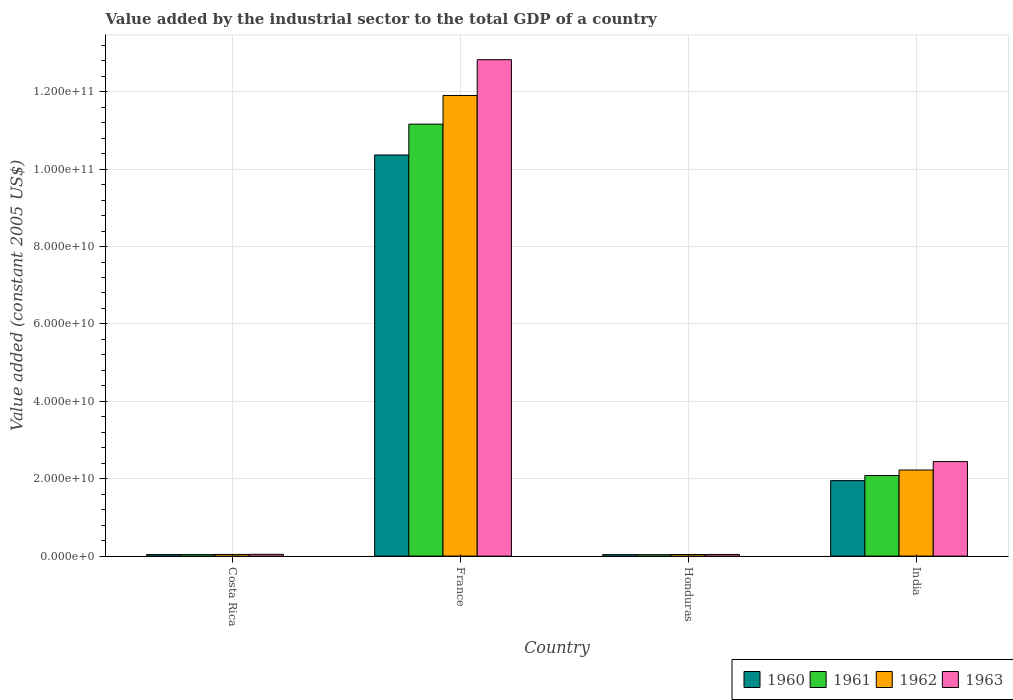How many different coloured bars are there?
Your response must be concise. 4. How many groups of bars are there?
Provide a succinct answer. 4. Are the number of bars per tick equal to the number of legend labels?
Ensure brevity in your answer.  Yes. What is the label of the 1st group of bars from the left?
Offer a very short reply. Costa Rica. In how many cases, is the number of bars for a given country not equal to the number of legend labels?
Provide a short and direct response. 0. What is the value added by the industrial sector in 1963 in Costa Rica?
Give a very brief answer. 4.68e+08. Across all countries, what is the maximum value added by the industrial sector in 1960?
Your answer should be compact. 1.04e+11. Across all countries, what is the minimum value added by the industrial sector in 1962?
Ensure brevity in your answer.  4.16e+08. In which country was the value added by the industrial sector in 1961 minimum?
Offer a very short reply. Honduras. What is the total value added by the industrial sector in 1961 in the graph?
Your answer should be very brief. 1.33e+11. What is the difference between the value added by the industrial sector in 1963 in Costa Rica and that in Honduras?
Keep it short and to the point. 4.49e+07. What is the difference between the value added by the industrial sector in 1960 in Costa Rica and the value added by the industrial sector in 1962 in France?
Ensure brevity in your answer.  -1.19e+11. What is the average value added by the industrial sector in 1963 per country?
Your answer should be compact. 3.84e+1. What is the difference between the value added by the industrial sector of/in 1961 and value added by the industrial sector of/in 1963 in Honduras?
Provide a short and direct response. -5.72e+07. What is the ratio of the value added by the industrial sector in 1960 in Costa Rica to that in France?
Provide a short and direct response. 0. Is the value added by the industrial sector in 1963 in France less than that in Honduras?
Your response must be concise. No. Is the difference between the value added by the industrial sector in 1961 in Costa Rica and India greater than the difference between the value added by the industrial sector in 1963 in Costa Rica and India?
Your answer should be very brief. Yes. What is the difference between the highest and the second highest value added by the industrial sector in 1962?
Give a very brief answer. 1.19e+11. What is the difference between the highest and the lowest value added by the industrial sector in 1961?
Keep it short and to the point. 1.11e+11. What does the 2nd bar from the left in Honduras represents?
Ensure brevity in your answer.  1961. What does the 3rd bar from the right in France represents?
Give a very brief answer. 1961. Are all the bars in the graph horizontal?
Offer a very short reply. No. Does the graph contain grids?
Ensure brevity in your answer.  Yes. Where does the legend appear in the graph?
Offer a very short reply. Bottom right. How are the legend labels stacked?
Provide a short and direct response. Horizontal. What is the title of the graph?
Offer a very short reply. Value added by the industrial sector to the total GDP of a country. Does "1986" appear as one of the legend labels in the graph?
Give a very brief answer. No. What is the label or title of the Y-axis?
Provide a succinct answer. Value added (constant 2005 US$). What is the Value added (constant 2005 US$) in 1960 in Costa Rica?
Your answer should be very brief. 3.98e+08. What is the Value added (constant 2005 US$) of 1961 in Costa Rica?
Offer a very short reply. 3.94e+08. What is the Value added (constant 2005 US$) of 1962 in Costa Rica?
Your response must be concise. 4.27e+08. What is the Value added (constant 2005 US$) of 1963 in Costa Rica?
Offer a very short reply. 4.68e+08. What is the Value added (constant 2005 US$) in 1960 in France?
Provide a short and direct response. 1.04e+11. What is the Value added (constant 2005 US$) in 1961 in France?
Keep it short and to the point. 1.12e+11. What is the Value added (constant 2005 US$) of 1962 in France?
Ensure brevity in your answer.  1.19e+11. What is the Value added (constant 2005 US$) in 1963 in France?
Your response must be concise. 1.28e+11. What is the Value added (constant 2005 US$) in 1960 in Honduras?
Provide a succinct answer. 3.75e+08. What is the Value added (constant 2005 US$) of 1961 in Honduras?
Provide a succinct answer. 3.66e+08. What is the Value added (constant 2005 US$) in 1962 in Honduras?
Your answer should be compact. 4.16e+08. What is the Value added (constant 2005 US$) of 1963 in Honduras?
Offer a terse response. 4.23e+08. What is the Value added (constant 2005 US$) in 1960 in India?
Provide a succinct answer. 1.95e+1. What is the Value added (constant 2005 US$) of 1961 in India?
Offer a terse response. 2.08e+1. What is the Value added (constant 2005 US$) of 1962 in India?
Ensure brevity in your answer.  2.22e+1. What is the Value added (constant 2005 US$) in 1963 in India?
Provide a succinct answer. 2.44e+1. Across all countries, what is the maximum Value added (constant 2005 US$) in 1960?
Ensure brevity in your answer.  1.04e+11. Across all countries, what is the maximum Value added (constant 2005 US$) of 1961?
Provide a short and direct response. 1.12e+11. Across all countries, what is the maximum Value added (constant 2005 US$) of 1962?
Your response must be concise. 1.19e+11. Across all countries, what is the maximum Value added (constant 2005 US$) of 1963?
Provide a succinct answer. 1.28e+11. Across all countries, what is the minimum Value added (constant 2005 US$) of 1960?
Offer a terse response. 3.75e+08. Across all countries, what is the minimum Value added (constant 2005 US$) in 1961?
Provide a succinct answer. 3.66e+08. Across all countries, what is the minimum Value added (constant 2005 US$) in 1962?
Provide a succinct answer. 4.16e+08. Across all countries, what is the minimum Value added (constant 2005 US$) in 1963?
Give a very brief answer. 4.23e+08. What is the total Value added (constant 2005 US$) in 1960 in the graph?
Offer a very short reply. 1.24e+11. What is the total Value added (constant 2005 US$) in 1961 in the graph?
Offer a very short reply. 1.33e+11. What is the total Value added (constant 2005 US$) in 1962 in the graph?
Your answer should be very brief. 1.42e+11. What is the total Value added (constant 2005 US$) of 1963 in the graph?
Your response must be concise. 1.54e+11. What is the difference between the Value added (constant 2005 US$) of 1960 in Costa Rica and that in France?
Ensure brevity in your answer.  -1.03e+11. What is the difference between the Value added (constant 2005 US$) of 1961 in Costa Rica and that in France?
Make the answer very short. -1.11e+11. What is the difference between the Value added (constant 2005 US$) of 1962 in Costa Rica and that in France?
Make the answer very short. -1.19e+11. What is the difference between the Value added (constant 2005 US$) in 1963 in Costa Rica and that in France?
Give a very brief answer. -1.28e+11. What is the difference between the Value added (constant 2005 US$) in 1960 in Costa Rica and that in Honduras?
Offer a very short reply. 2.26e+07. What is the difference between the Value added (constant 2005 US$) in 1961 in Costa Rica and that in Honduras?
Provide a short and direct response. 2.78e+07. What is the difference between the Value added (constant 2005 US$) in 1962 in Costa Rica and that in Honduras?
Provide a succinct answer. 1.10e+07. What is the difference between the Value added (constant 2005 US$) of 1963 in Costa Rica and that in Honduras?
Ensure brevity in your answer.  4.49e+07. What is the difference between the Value added (constant 2005 US$) in 1960 in Costa Rica and that in India?
Keep it short and to the point. -1.91e+1. What is the difference between the Value added (constant 2005 US$) of 1961 in Costa Rica and that in India?
Ensure brevity in your answer.  -2.04e+1. What is the difference between the Value added (constant 2005 US$) of 1962 in Costa Rica and that in India?
Ensure brevity in your answer.  -2.18e+1. What is the difference between the Value added (constant 2005 US$) of 1963 in Costa Rica and that in India?
Offer a very short reply. -2.40e+1. What is the difference between the Value added (constant 2005 US$) in 1960 in France and that in Honduras?
Keep it short and to the point. 1.03e+11. What is the difference between the Value added (constant 2005 US$) of 1961 in France and that in Honduras?
Provide a succinct answer. 1.11e+11. What is the difference between the Value added (constant 2005 US$) of 1962 in France and that in Honduras?
Ensure brevity in your answer.  1.19e+11. What is the difference between the Value added (constant 2005 US$) in 1963 in France and that in Honduras?
Your response must be concise. 1.28e+11. What is the difference between the Value added (constant 2005 US$) in 1960 in France and that in India?
Your response must be concise. 8.42e+1. What is the difference between the Value added (constant 2005 US$) of 1961 in France and that in India?
Keep it short and to the point. 9.08e+1. What is the difference between the Value added (constant 2005 US$) of 1962 in France and that in India?
Your answer should be compact. 9.68e+1. What is the difference between the Value added (constant 2005 US$) in 1963 in France and that in India?
Your answer should be very brief. 1.04e+11. What is the difference between the Value added (constant 2005 US$) in 1960 in Honduras and that in India?
Your answer should be very brief. -1.91e+1. What is the difference between the Value added (constant 2005 US$) of 1961 in Honduras and that in India?
Make the answer very short. -2.05e+1. What is the difference between the Value added (constant 2005 US$) of 1962 in Honduras and that in India?
Keep it short and to the point. -2.18e+1. What is the difference between the Value added (constant 2005 US$) in 1963 in Honduras and that in India?
Provide a short and direct response. -2.40e+1. What is the difference between the Value added (constant 2005 US$) of 1960 in Costa Rica and the Value added (constant 2005 US$) of 1961 in France?
Make the answer very short. -1.11e+11. What is the difference between the Value added (constant 2005 US$) in 1960 in Costa Rica and the Value added (constant 2005 US$) in 1962 in France?
Ensure brevity in your answer.  -1.19e+11. What is the difference between the Value added (constant 2005 US$) of 1960 in Costa Rica and the Value added (constant 2005 US$) of 1963 in France?
Provide a short and direct response. -1.28e+11. What is the difference between the Value added (constant 2005 US$) in 1961 in Costa Rica and the Value added (constant 2005 US$) in 1962 in France?
Make the answer very short. -1.19e+11. What is the difference between the Value added (constant 2005 US$) of 1961 in Costa Rica and the Value added (constant 2005 US$) of 1963 in France?
Offer a terse response. -1.28e+11. What is the difference between the Value added (constant 2005 US$) in 1962 in Costa Rica and the Value added (constant 2005 US$) in 1963 in France?
Ensure brevity in your answer.  -1.28e+11. What is the difference between the Value added (constant 2005 US$) in 1960 in Costa Rica and the Value added (constant 2005 US$) in 1961 in Honduras?
Provide a short and direct response. 3.20e+07. What is the difference between the Value added (constant 2005 US$) in 1960 in Costa Rica and the Value added (constant 2005 US$) in 1962 in Honduras?
Make the answer very short. -1.81e+07. What is the difference between the Value added (constant 2005 US$) in 1960 in Costa Rica and the Value added (constant 2005 US$) in 1963 in Honduras?
Your answer should be compact. -2.52e+07. What is the difference between the Value added (constant 2005 US$) of 1961 in Costa Rica and the Value added (constant 2005 US$) of 1962 in Honduras?
Give a very brief answer. -2.22e+07. What is the difference between the Value added (constant 2005 US$) of 1961 in Costa Rica and the Value added (constant 2005 US$) of 1963 in Honduras?
Provide a succinct answer. -2.94e+07. What is the difference between the Value added (constant 2005 US$) in 1962 in Costa Rica and the Value added (constant 2005 US$) in 1963 in Honduras?
Ensure brevity in your answer.  3.81e+06. What is the difference between the Value added (constant 2005 US$) of 1960 in Costa Rica and the Value added (constant 2005 US$) of 1961 in India?
Offer a terse response. -2.04e+1. What is the difference between the Value added (constant 2005 US$) of 1960 in Costa Rica and the Value added (constant 2005 US$) of 1962 in India?
Offer a terse response. -2.18e+1. What is the difference between the Value added (constant 2005 US$) of 1960 in Costa Rica and the Value added (constant 2005 US$) of 1963 in India?
Offer a terse response. -2.40e+1. What is the difference between the Value added (constant 2005 US$) of 1961 in Costa Rica and the Value added (constant 2005 US$) of 1962 in India?
Give a very brief answer. -2.19e+1. What is the difference between the Value added (constant 2005 US$) in 1961 in Costa Rica and the Value added (constant 2005 US$) in 1963 in India?
Offer a terse response. -2.40e+1. What is the difference between the Value added (constant 2005 US$) in 1962 in Costa Rica and the Value added (constant 2005 US$) in 1963 in India?
Provide a succinct answer. -2.40e+1. What is the difference between the Value added (constant 2005 US$) of 1960 in France and the Value added (constant 2005 US$) of 1961 in Honduras?
Ensure brevity in your answer.  1.03e+11. What is the difference between the Value added (constant 2005 US$) of 1960 in France and the Value added (constant 2005 US$) of 1962 in Honduras?
Offer a terse response. 1.03e+11. What is the difference between the Value added (constant 2005 US$) in 1960 in France and the Value added (constant 2005 US$) in 1963 in Honduras?
Make the answer very short. 1.03e+11. What is the difference between the Value added (constant 2005 US$) of 1961 in France and the Value added (constant 2005 US$) of 1962 in Honduras?
Your answer should be very brief. 1.11e+11. What is the difference between the Value added (constant 2005 US$) of 1961 in France and the Value added (constant 2005 US$) of 1963 in Honduras?
Keep it short and to the point. 1.11e+11. What is the difference between the Value added (constant 2005 US$) in 1962 in France and the Value added (constant 2005 US$) in 1963 in Honduras?
Offer a terse response. 1.19e+11. What is the difference between the Value added (constant 2005 US$) of 1960 in France and the Value added (constant 2005 US$) of 1961 in India?
Provide a short and direct response. 8.28e+1. What is the difference between the Value added (constant 2005 US$) of 1960 in France and the Value added (constant 2005 US$) of 1962 in India?
Make the answer very short. 8.14e+1. What is the difference between the Value added (constant 2005 US$) of 1960 in France and the Value added (constant 2005 US$) of 1963 in India?
Ensure brevity in your answer.  7.92e+1. What is the difference between the Value added (constant 2005 US$) of 1961 in France and the Value added (constant 2005 US$) of 1962 in India?
Your answer should be compact. 8.94e+1. What is the difference between the Value added (constant 2005 US$) of 1961 in France and the Value added (constant 2005 US$) of 1963 in India?
Give a very brief answer. 8.72e+1. What is the difference between the Value added (constant 2005 US$) of 1962 in France and the Value added (constant 2005 US$) of 1963 in India?
Provide a succinct answer. 9.46e+1. What is the difference between the Value added (constant 2005 US$) in 1960 in Honduras and the Value added (constant 2005 US$) in 1961 in India?
Provide a short and direct response. -2.05e+1. What is the difference between the Value added (constant 2005 US$) in 1960 in Honduras and the Value added (constant 2005 US$) in 1962 in India?
Your answer should be very brief. -2.19e+1. What is the difference between the Value added (constant 2005 US$) of 1960 in Honduras and the Value added (constant 2005 US$) of 1963 in India?
Your answer should be compact. -2.41e+1. What is the difference between the Value added (constant 2005 US$) in 1961 in Honduras and the Value added (constant 2005 US$) in 1962 in India?
Provide a succinct answer. -2.19e+1. What is the difference between the Value added (constant 2005 US$) in 1961 in Honduras and the Value added (constant 2005 US$) in 1963 in India?
Your answer should be very brief. -2.41e+1. What is the difference between the Value added (constant 2005 US$) in 1962 in Honduras and the Value added (constant 2005 US$) in 1963 in India?
Offer a very short reply. -2.40e+1. What is the average Value added (constant 2005 US$) of 1960 per country?
Your answer should be compact. 3.10e+1. What is the average Value added (constant 2005 US$) of 1961 per country?
Give a very brief answer. 3.33e+1. What is the average Value added (constant 2005 US$) of 1962 per country?
Make the answer very short. 3.55e+1. What is the average Value added (constant 2005 US$) in 1963 per country?
Your response must be concise. 3.84e+1. What is the difference between the Value added (constant 2005 US$) in 1960 and Value added (constant 2005 US$) in 1961 in Costa Rica?
Your answer should be very brief. 4.19e+06. What is the difference between the Value added (constant 2005 US$) in 1960 and Value added (constant 2005 US$) in 1962 in Costa Rica?
Offer a terse response. -2.91e+07. What is the difference between the Value added (constant 2005 US$) in 1960 and Value added (constant 2005 US$) in 1963 in Costa Rica?
Your answer should be very brief. -7.01e+07. What is the difference between the Value added (constant 2005 US$) of 1961 and Value added (constant 2005 US$) of 1962 in Costa Rica?
Your response must be concise. -3.32e+07. What is the difference between the Value added (constant 2005 US$) of 1961 and Value added (constant 2005 US$) of 1963 in Costa Rica?
Provide a short and direct response. -7.43e+07. What is the difference between the Value added (constant 2005 US$) in 1962 and Value added (constant 2005 US$) in 1963 in Costa Rica?
Keep it short and to the point. -4.11e+07. What is the difference between the Value added (constant 2005 US$) of 1960 and Value added (constant 2005 US$) of 1961 in France?
Ensure brevity in your answer.  -7.97e+09. What is the difference between the Value added (constant 2005 US$) in 1960 and Value added (constant 2005 US$) in 1962 in France?
Give a very brief answer. -1.54e+1. What is the difference between the Value added (constant 2005 US$) of 1960 and Value added (constant 2005 US$) of 1963 in France?
Your response must be concise. -2.46e+1. What is the difference between the Value added (constant 2005 US$) in 1961 and Value added (constant 2005 US$) in 1962 in France?
Make the answer very short. -7.41e+09. What is the difference between the Value added (constant 2005 US$) of 1961 and Value added (constant 2005 US$) of 1963 in France?
Provide a succinct answer. -1.67e+1. What is the difference between the Value added (constant 2005 US$) of 1962 and Value added (constant 2005 US$) of 1963 in France?
Ensure brevity in your answer.  -9.25e+09. What is the difference between the Value added (constant 2005 US$) of 1960 and Value added (constant 2005 US$) of 1961 in Honduras?
Give a very brief answer. 9.37e+06. What is the difference between the Value added (constant 2005 US$) in 1960 and Value added (constant 2005 US$) in 1962 in Honduras?
Keep it short and to the point. -4.07e+07. What is the difference between the Value added (constant 2005 US$) in 1960 and Value added (constant 2005 US$) in 1963 in Honduras?
Ensure brevity in your answer.  -4.79e+07. What is the difference between the Value added (constant 2005 US$) of 1961 and Value added (constant 2005 US$) of 1962 in Honduras?
Give a very brief answer. -5.00e+07. What is the difference between the Value added (constant 2005 US$) in 1961 and Value added (constant 2005 US$) in 1963 in Honduras?
Your response must be concise. -5.72e+07. What is the difference between the Value added (constant 2005 US$) of 1962 and Value added (constant 2005 US$) of 1963 in Honduras?
Offer a terse response. -7.19e+06. What is the difference between the Value added (constant 2005 US$) of 1960 and Value added (constant 2005 US$) of 1961 in India?
Keep it short and to the point. -1.32e+09. What is the difference between the Value added (constant 2005 US$) in 1960 and Value added (constant 2005 US$) in 1962 in India?
Keep it short and to the point. -2.74e+09. What is the difference between the Value added (constant 2005 US$) in 1960 and Value added (constant 2005 US$) in 1963 in India?
Offer a terse response. -4.92e+09. What is the difference between the Value added (constant 2005 US$) of 1961 and Value added (constant 2005 US$) of 1962 in India?
Provide a succinct answer. -1.42e+09. What is the difference between the Value added (constant 2005 US$) in 1961 and Value added (constant 2005 US$) in 1963 in India?
Your response must be concise. -3.60e+09. What is the difference between the Value added (constant 2005 US$) in 1962 and Value added (constant 2005 US$) in 1963 in India?
Ensure brevity in your answer.  -2.18e+09. What is the ratio of the Value added (constant 2005 US$) of 1960 in Costa Rica to that in France?
Your answer should be compact. 0. What is the ratio of the Value added (constant 2005 US$) of 1961 in Costa Rica to that in France?
Provide a short and direct response. 0. What is the ratio of the Value added (constant 2005 US$) of 1962 in Costa Rica to that in France?
Provide a succinct answer. 0. What is the ratio of the Value added (constant 2005 US$) of 1963 in Costa Rica to that in France?
Keep it short and to the point. 0. What is the ratio of the Value added (constant 2005 US$) in 1960 in Costa Rica to that in Honduras?
Give a very brief answer. 1.06. What is the ratio of the Value added (constant 2005 US$) in 1961 in Costa Rica to that in Honduras?
Your response must be concise. 1.08. What is the ratio of the Value added (constant 2005 US$) of 1962 in Costa Rica to that in Honduras?
Ensure brevity in your answer.  1.03. What is the ratio of the Value added (constant 2005 US$) of 1963 in Costa Rica to that in Honduras?
Ensure brevity in your answer.  1.11. What is the ratio of the Value added (constant 2005 US$) in 1960 in Costa Rica to that in India?
Provide a succinct answer. 0.02. What is the ratio of the Value added (constant 2005 US$) in 1961 in Costa Rica to that in India?
Your answer should be compact. 0.02. What is the ratio of the Value added (constant 2005 US$) in 1962 in Costa Rica to that in India?
Provide a succinct answer. 0.02. What is the ratio of the Value added (constant 2005 US$) in 1963 in Costa Rica to that in India?
Your response must be concise. 0.02. What is the ratio of the Value added (constant 2005 US$) of 1960 in France to that in Honduras?
Your answer should be compact. 276.31. What is the ratio of the Value added (constant 2005 US$) in 1961 in France to that in Honduras?
Your answer should be very brief. 305.16. What is the ratio of the Value added (constant 2005 US$) in 1962 in France to that in Honduras?
Offer a very short reply. 286.26. What is the ratio of the Value added (constant 2005 US$) in 1963 in France to that in Honduras?
Offer a very short reply. 303.25. What is the ratio of the Value added (constant 2005 US$) in 1960 in France to that in India?
Your answer should be very brief. 5.32. What is the ratio of the Value added (constant 2005 US$) in 1961 in France to that in India?
Ensure brevity in your answer.  5.36. What is the ratio of the Value added (constant 2005 US$) in 1962 in France to that in India?
Make the answer very short. 5.35. What is the ratio of the Value added (constant 2005 US$) in 1963 in France to that in India?
Provide a succinct answer. 5.25. What is the ratio of the Value added (constant 2005 US$) of 1960 in Honduras to that in India?
Provide a short and direct response. 0.02. What is the ratio of the Value added (constant 2005 US$) in 1961 in Honduras to that in India?
Offer a very short reply. 0.02. What is the ratio of the Value added (constant 2005 US$) of 1962 in Honduras to that in India?
Your answer should be very brief. 0.02. What is the ratio of the Value added (constant 2005 US$) in 1963 in Honduras to that in India?
Keep it short and to the point. 0.02. What is the difference between the highest and the second highest Value added (constant 2005 US$) in 1960?
Provide a succinct answer. 8.42e+1. What is the difference between the highest and the second highest Value added (constant 2005 US$) in 1961?
Your response must be concise. 9.08e+1. What is the difference between the highest and the second highest Value added (constant 2005 US$) in 1962?
Ensure brevity in your answer.  9.68e+1. What is the difference between the highest and the second highest Value added (constant 2005 US$) in 1963?
Make the answer very short. 1.04e+11. What is the difference between the highest and the lowest Value added (constant 2005 US$) in 1960?
Provide a short and direct response. 1.03e+11. What is the difference between the highest and the lowest Value added (constant 2005 US$) in 1961?
Your response must be concise. 1.11e+11. What is the difference between the highest and the lowest Value added (constant 2005 US$) of 1962?
Your answer should be very brief. 1.19e+11. What is the difference between the highest and the lowest Value added (constant 2005 US$) in 1963?
Keep it short and to the point. 1.28e+11. 